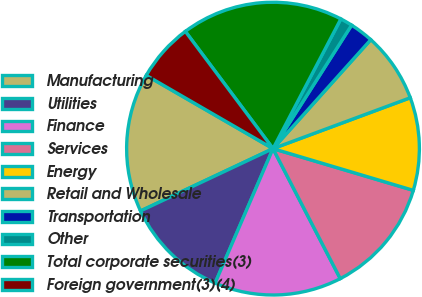Convert chart to OTSL. <chart><loc_0><loc_0><loc_500><loc_500><pie_chart><fcel>Manufacturing<fcel>Utilities<fcel>Finance<fcel>Services<fcel>Energy<fcel>Retail and Wholesale<fcel>Transportation<fcel>Other<fcel>Total corporate securities(3)<fcel>Foreign government(3)(4)<nl><fcel>15.34%<fcel>11.53%<fcel>14.07%<fcel>12.8%<fcel>10.25%<fcel>7.71%<fcel>2.62%<fcel>1.35%<fcel>17.89%<fcel>6.44%<nl></chart> 